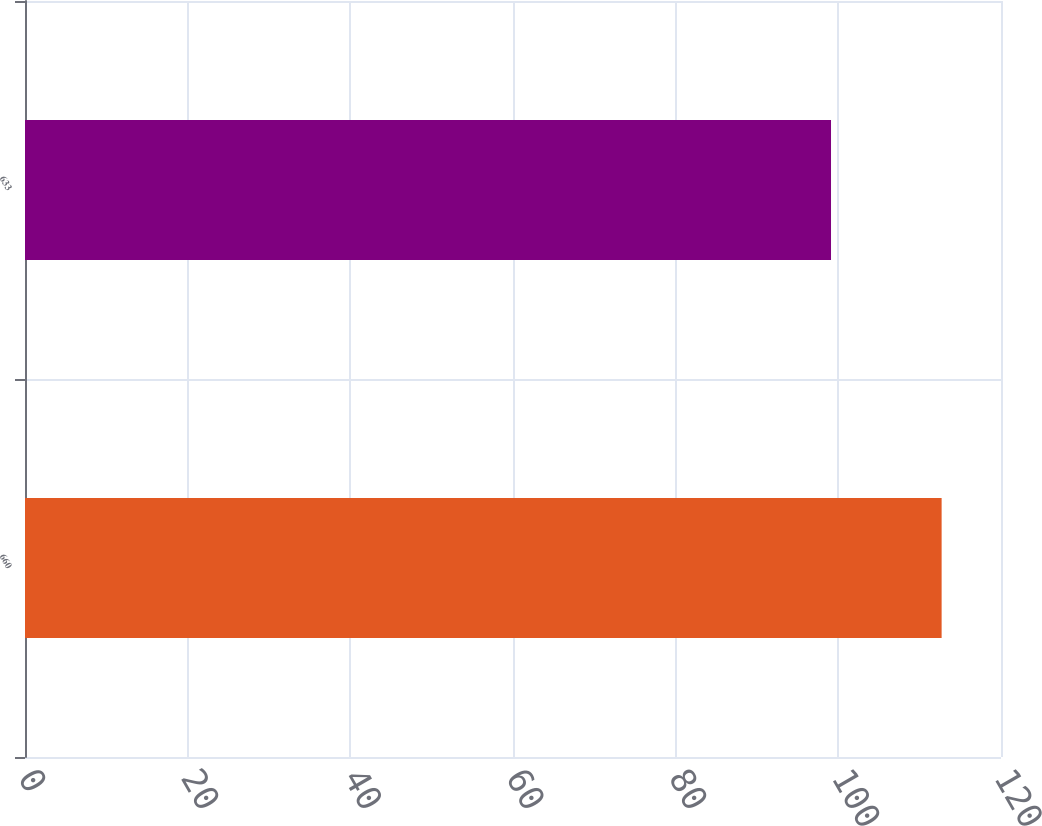<chart> <loc_0><loc_0><loc_500><loc_500><bar_chart><fcel>660<fcel>633<nl><fcel>112.7<fcel>99.1<nl></chart> 